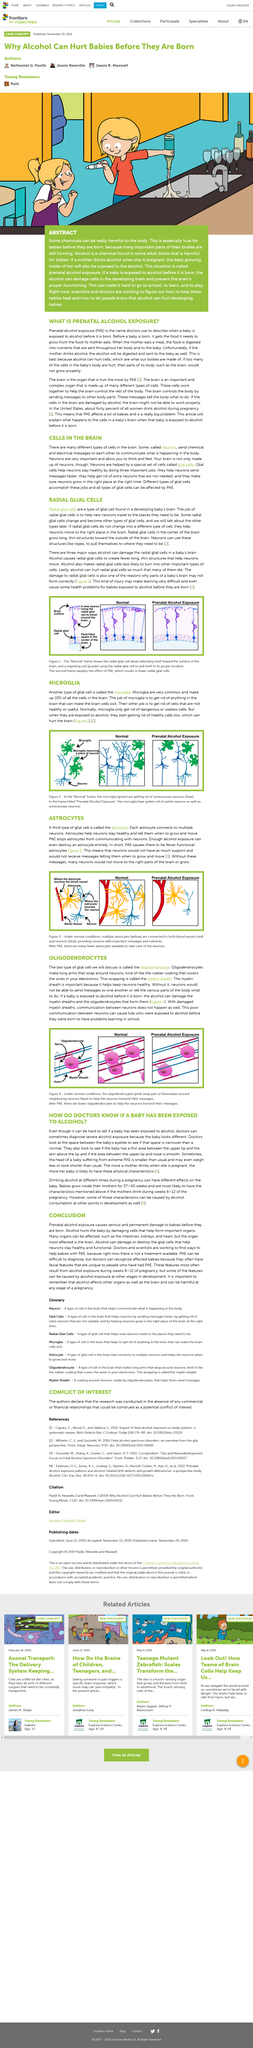Highlight a few significant elements in this photo. Radial glial cells are responsible for guiding newly generated neurons to their proper destinations in the developing brain. Astrocytes are cells that play a vital role in maintaining the health of neurons and instructing them to grow and move. One of their key functions is to help neurons stay healthy. Additionally, astrocytes are capable of detecting changes in the environment and communicating this information to neurons, allowing them to adapt and respond accordingly. Alcohol consumption can lead to the destruction of astrocytes, which are a type of glial cell in the brain. This destruction can have detrimental effects on brain function and overall health. Prenatal Alcohol Exposure" is a term that refers to the harmful effects that alcohol consumption has on an unborn baby during pregnancy. Alcohol, a chemical found in some adult drinks, is harmful for babies and should not be given to them. 